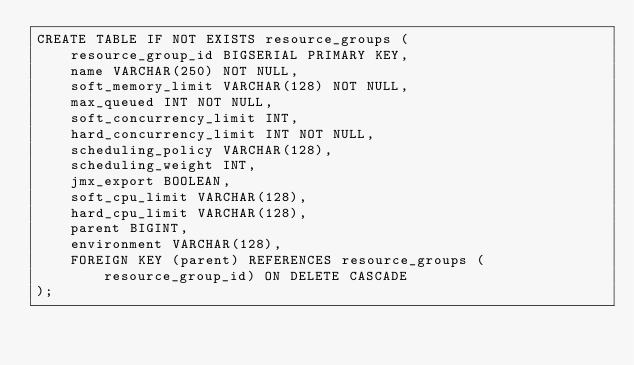Convert code to text. <code><loc_0><loc_0><loc_500><loc_500><_SQL_>CREATE TABLE IF NOT EXISTS resource_groups (
    resource_group_id BIGSERIAL PRIMARY KEY,
    name VARCHAR(250) NOT NULL,
    soft_memory_limit VARCHAR(128) NOT NULL,
    max_queued INT NOT NULL,
    soft_concurrency_limit INT,
    hard_concurrency_limit INT NOT NULL,
    scheduling_policy VARCHAR(128),
    scheduling_weight INT,
    jmx_export BOOLEAN,
    soft_cpu_limit VARCHAR(128),
    hard_cpu_limit VARCHAR(128),
    parent BIGINT,
    environment VARCHAR(128),
    FOREIGN KEY (parent) REFERENCES resource_groups (resource_group_id) ON DELETE CASCADE
);
</code> 